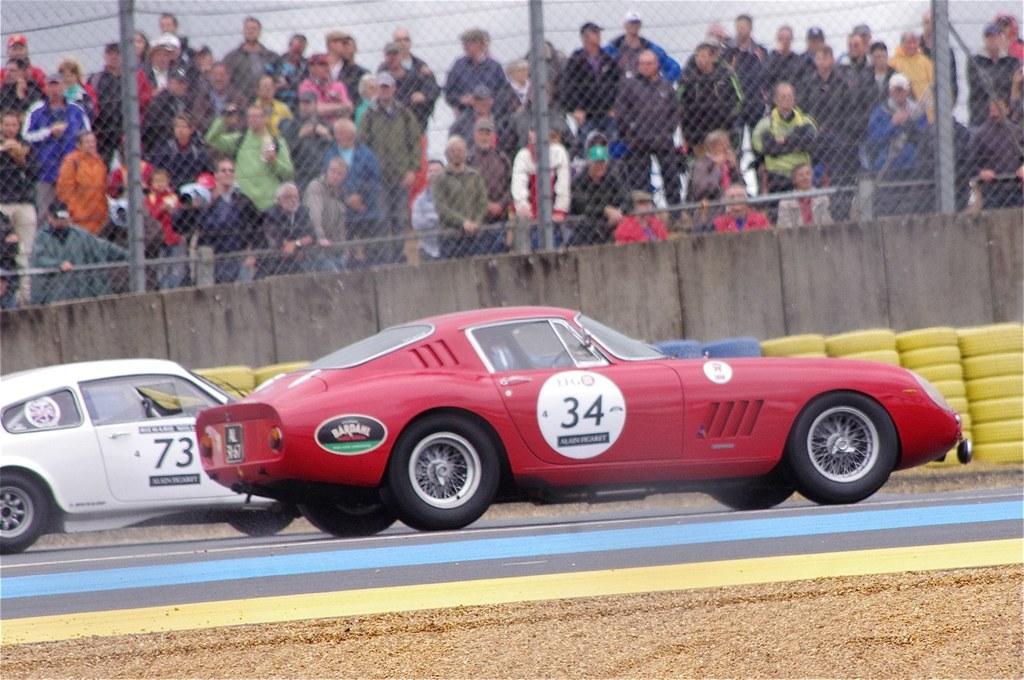Please provide a concise description of this image. In this picture I can see the red and white car on the road. Behind that I can see the yellow and blue colour tires which are placed near to the wooden partition and fencing. Behind the fencing I can see many peoples who are standing. At the top I can see the wires and sky. 